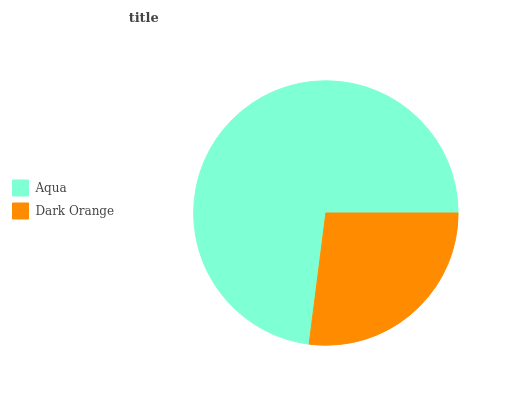Is Dark Orange the minimum?
Answer yes or no. Yes. Is Aqua the maximum?
Answer yes or no. Yes. Is Dark Orange the maximum?
Answer yes or no. No. Is Aqua greater than Dark Orange?
Answer yes or no. Yes. Is Dark Orange less than Aqua?
Answer yes or no. Yes. Is Dark Orange greater than Aqua?
Answer yes or no. No. Is Aqua less than Dark Orange?
Answer yes or no. No. Is Aqua the high median?
Answer yes or no. Yes. Is Dark Orange the low median?
Answer yes or no. Yes. Is Dark Orange the high median?
Answer yes or no. No. Is Aqua the low median?
Answer yes or no. No. 